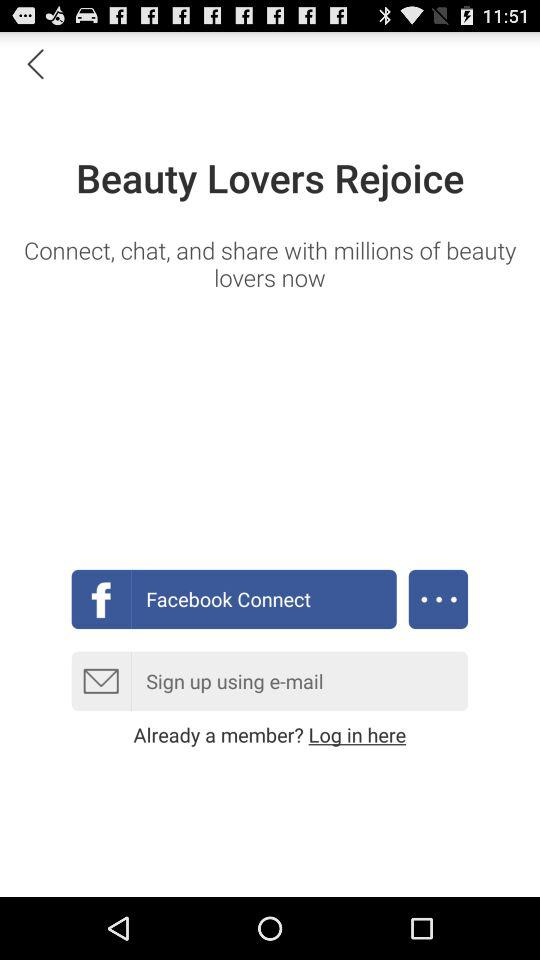Which application can we use to sign up? The application is "Facebook". 